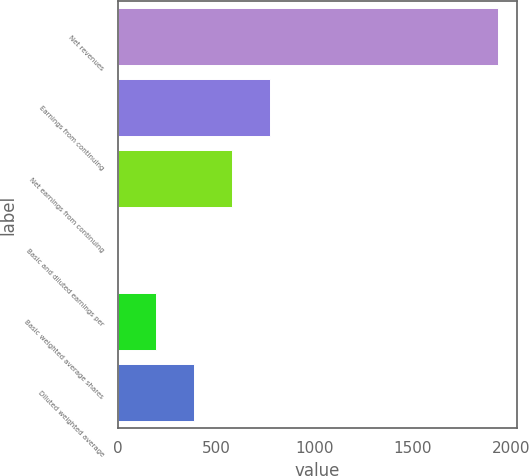Convert chart to OTSL. <chart><loc_0><loc_0><loc_500><loc_500><bar_chart><fcel>Net revenues<fcel>Earnings from continuing<fcel>Net earnings from continuing<fcel>Basic and diluted earnings per<fcel>Basic weighted average shares<fcel>Diluted weighted average<nl><fcel>1933.3<fcel>774.1<fcel>580.9<fcel>1.3<fcel>194.5<fcel>387.7<nl></chart> 